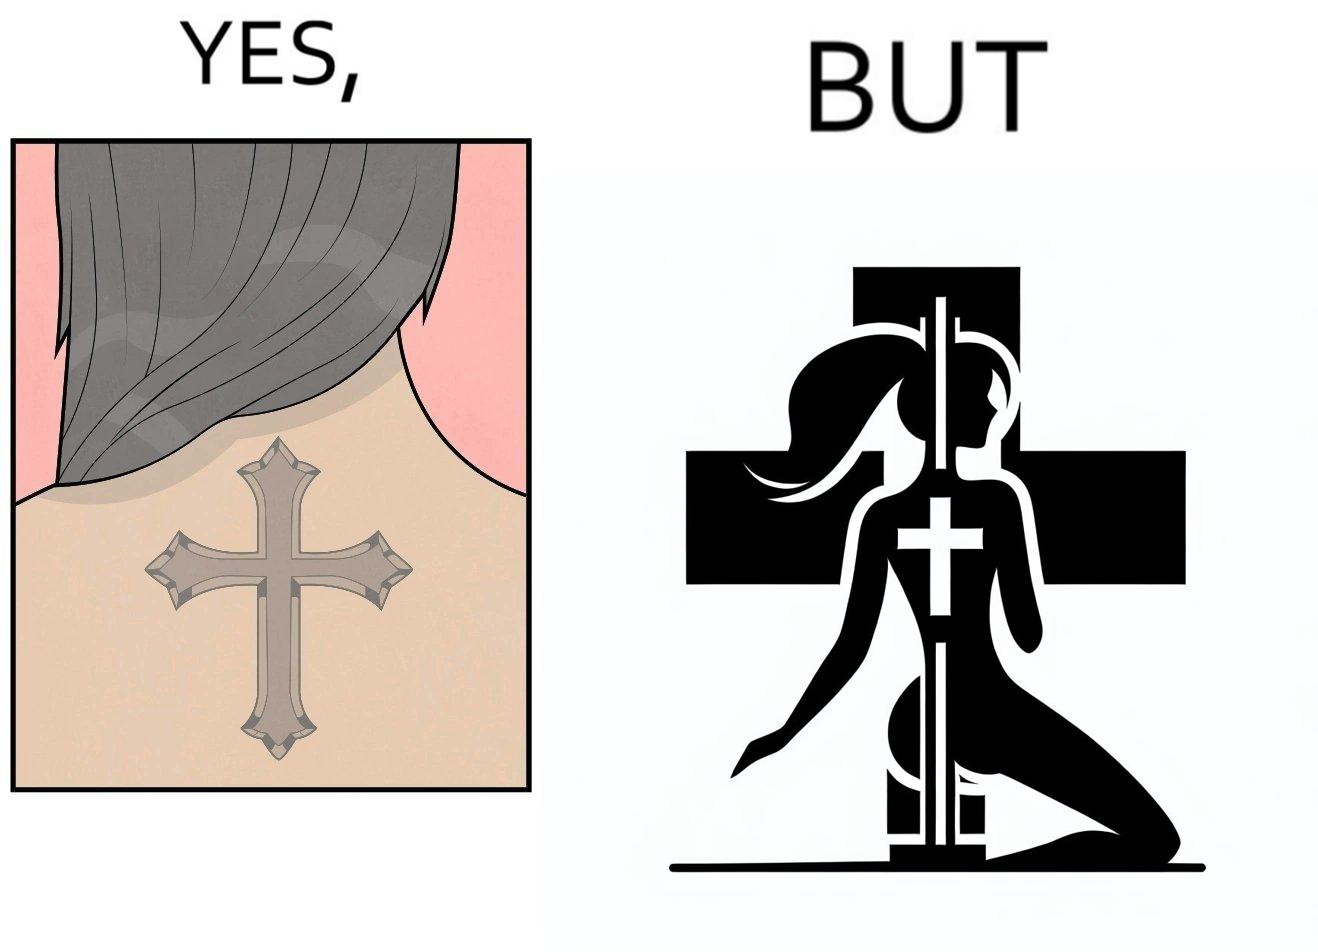Describe the content of this image. This image may present two different ideas, firstly even she is such a believer in god that she has got a tatto of holy cross symbol on her back but her situations have forced her to do a job at a bar or some place performing pole dance and secondly she is using a religious symbol to glorify her look so that more people acknowledge her dance and give her some money 